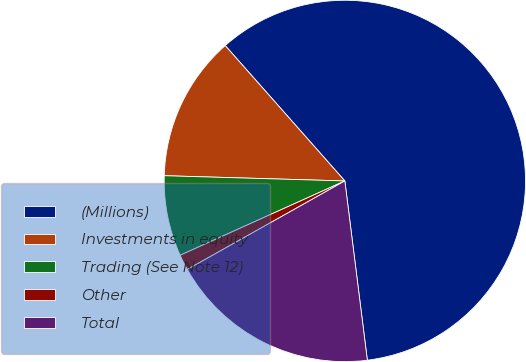Convert chart to OTSL. <chart><loc_0><loc_0><loc_500><loc_500><pie_chart><fcel>(Millions)<fcel>Investments in equity<fcel>Trading (See Note 12)<fcel>Other<fcel>Total<nl><fcel>59.53%<fcel>13.02%<fcel>7.21%<fcel>1.4%<fcel>18.84%<nl></chart> 